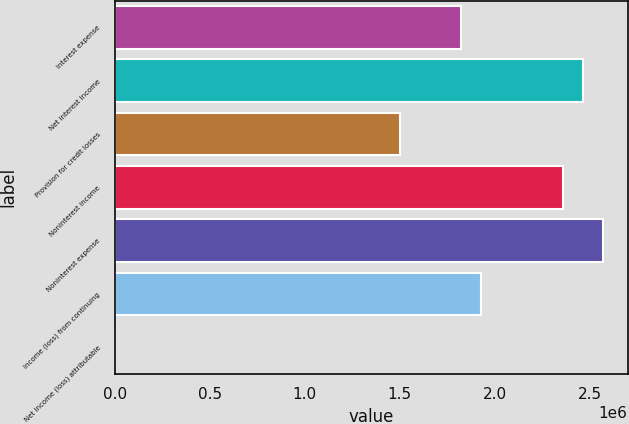<chart> <loc_0><loc_0><loc_500><loc_500><bar_chart><fcel>Interest expense<fcel>Net interest income<fcel>Provision for credit losses<fcel>Noninterest income<fcel>Noninterest expense<fcel>Income (loss) from continuing<fcel>Net income (loss) attributable<nl><fcel>1.82204e+06<fcel>2.46511e+06<fcel>1.5005e+06<fcel>2.35793e+06<fcel>2.57229e+06<fcel>1.92921e+06<fcel>0.38<nl></chart> 